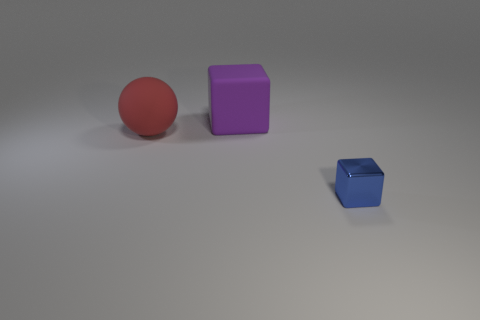What shape is the object that is made of the same material as the red ball?
Your answer should be very brief. Cube. What number of big red rubber things are on the left side of the object right of the block that is behind the small blue cube?
Your answer should be compact. 1. There is a thing that is on the left side of the small object and on the right side of the large red ball; what shape is it?
Ensure brevity in your answer.  Cube. Are there fewer big objects on the left side of the big red matte sphere than big blue rubber spheres?
Offer a very short reply. No. What number of large things are cyan metallic cubes or purple matte cubes?
Your response must be concise. 1. How big is the matte ball?
Ensure brevity in your answer.  Large. Is there anything else that has the same material as the blue cube?
Ensure brevity in your answer.  No. There is a purple object; what number of red spheres are in front of it?
Provide a succinct answer. 1. There is a blue metallic thing that is the same shape as the big purple matte object; what size is it?
Provide a short and direct response. Small. There is a object that is in front of the large matte cube and to the right of the large red thing; what size is it?
Make the answer very short. Small. 